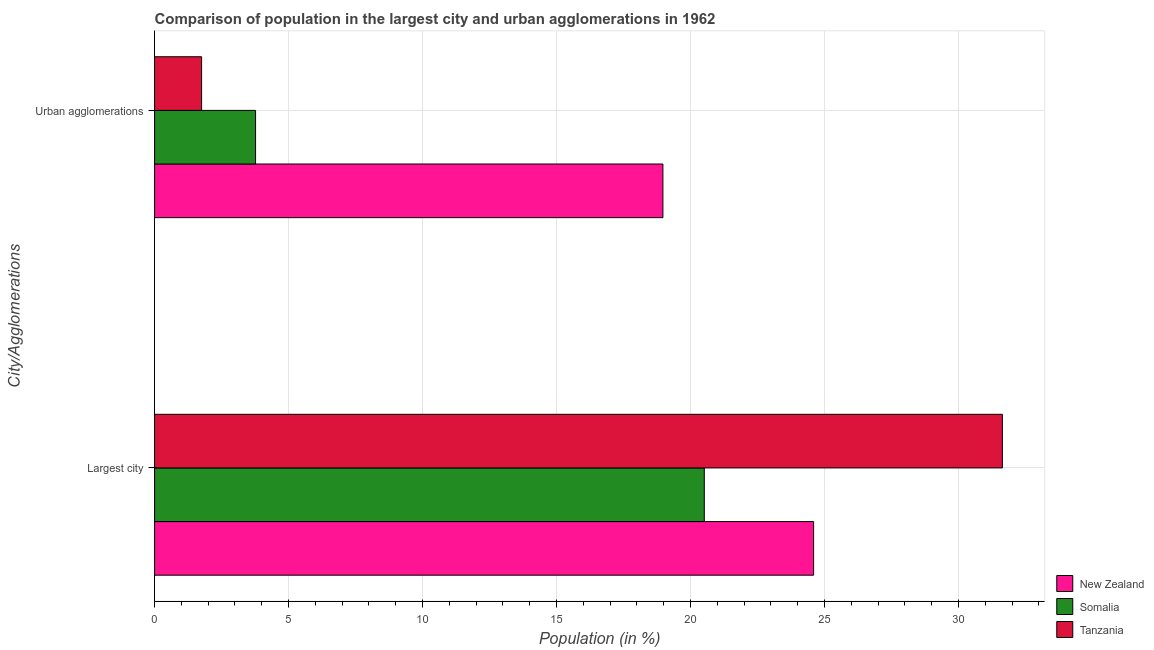How many different coloured bars are there?
Provide a succinct answer. 3. How many groups of bars are there?
Your answer should be very brief. 2. How many bars are there on the 1st tick from the top?
Your answer should be compact. 3. How many bars are there on the 2nd tick from the bottom?
Provide a succinct answer. 3. What is the label of the 1st group of bars from the top?
Offer a very short reply. Urban agglomerations. What is the population in urban agglomerations in Somalia?
Your answer should be very brief. 3.77. Across all countries, what is the maximum population in urban agglomerations?
Your response must be concise. 18.97. Across all countries, what is the minimum population in the largest city?
Offer a terse response. 20.52. In which country was the population in the largest city maximum?
Make the answer very short. Tanzania. In which country was the population in urban agglomerations minimum?
Keep it short and to the point. Tanzania. What is the total population in the largest city in the graph?
Provide a short and direct response. 76.75. What is the difference between the population in urban agglomerations in New Zealand and that in Tanzania?
Your answer should be compact. 17.22. What is the difference between the population in urban agglomerations in Somalia and the population in the largest city in Tanzania?
Provide a short and direct response. -27.87. What is the average population in the largest city per country?
Keep it short and to the point. 25.58. What is the difference between the population in urban agglomerations and population in the largest city in New Zealand?
Offer a very short reply. -5.62. In how many countries, is the population in urban agglomerations greater than 28 %?
Your answer should be very brief. 0. What is the ratio of the population in urban agglomerations in Tanzania to that in New Zealand?
Your answer should be very brief. 0.09. What does the 3rd bar from the top in Largest city represents?
Your response must be concise. New Zealand. What does the 3rd bar from the bottom in Urban agglomerations represents?
Your answer should be very brief. Tanzania. How many bars are there?
Your response must be concise. 6. Are all the bars in the graph horizontal?
Your answer should be very brief. Yes. How many countries are there in the graph?
Provide a short and direct response. 3. What is the difference between two consecutive major ticks on the X-axis?
Your answer should be very brief. 5. What is the title of the graph?
Your answer should be compact. Comparison of population in the largest city and urban agglomerations in 1962. Does "Least developed countries" appear as one of the legend labels in the graph?
Ensure brevity in your answer.  No. What is the label or title of the X-axis?
Your answer should be compact. Population (in %). What is the label or title of the Y-axis?
Make the answer very short. City/Agglomerations. What is the Population (in %) in New Zealand in Largest city?
Provide a short and direct response. 24.6. What is the Population (in %) in Somalia in Largest city?
Provide a short and direct response. 20.52. What is the Population (in %) of Tanzania in Largest city?
Your response must be concise. 31.64. What is the Population (in %) of New Zealand in Urban agglomerations?
Offer a terse response. 18.97. What is the Population (in %) in Somalia in Urban agglomerations?
Your answer should be compact. 3.77. What is the Population (in %) in Tanzania in Urban agglomerations?
Make the answer very short. 1.76. Across all City/Agglomerations, what is the maximum Population (in %) in New Zealand?
Make the answer very short. 24.6. Across all City/Agglomerations, what is the maximum Population (in %) in Somalia?
Provide a short and direct response. 20.52. Across all City/Agglomerations, what is the maximum Population (in %) in Tanzania?
Your answer should be compact. 31.64. Across all City/Agglomerations, what is the minimum Population (in %) in New Zealand?
Your response must be concise. 18.97. Across all City/Agglomerations, what is the minimum Population (in %) in Somalia?
Provide a succinct answer. 3.77. Across all City/Agglomerations, what is the minimum Population (in %) in Tanzania?
Provide a succinct answer. 1.76. What is the total Population (in %) in New Zealand in the graph?
Provide a short and direct response. 43.57. What is the total Population (in %) in Somalia in the graph?
Offer a terse response. 24.28. What is the total Population (in %) in Tanzania in the graph?
Offer a very short reply. 33.39. What is the difference between the Population (in %) in New Zealand in Largest city and that in Urban agglomerations?
Your answer should be very brief. 5.62. What is the difference between the Population (in %) in Somalia in Largest city and that in Urban agglomerations?
Your response must be concise. 16.75. What is the difference between the Population (in %) in Tanzania in Largest city and that in Urban agglomerations?
Make the answer very short. 29.88. What is the difference between the Population (in %) in New Zealand in Largest city and the Population (in %) in Somalia in Urban agglomerations?
Give a very brief answer. 20.83. What is the difference between the Population (in %) of New Zealand in Largest city and the Population (in %) of Tanzania in Urban agglomerations?
Offer a very short reply. 22.84. What is the difference between the Population (in %) in Somalia in Largest city and the Population (in %) in Tanzania in Urban agglomerations?
Provide a short and direct response. 18.76. What is the average Population (in %) of New Zealand per City/Agglomerations?
Make the answer very short. 21.78. What is the average Population (in %) of Somalia per City/Agglomerations?
Your answer should be compact. 12.14. What is the average Population (in %) in Tanzania per City/Agglomerations?
Ensure brevity in your answer.  16.7. What is the difference between the Population (in %) in New Zealand and Population (in %) in Somalia in Largest city?
Offer a very short reply. 4.08. What is the difference between the Population (in %) in New Zealand and Population (in %) in Tanzania in Largest city?
Your response must be concise. -7.04. What is the difference between the Population (in %) of Somalia and Population (in %) of Tanzania in Largest city?
Your answer should be very brief. -11.12. What is the difference between the Population (in %) of New Zealand and Population (in %) of Somalia in Urban agglomerations?
Provide a short and direct response. 15.2. What is the difference between the Population (in %) in New Zealand and Population (in %) in Tanzania in Urban agglomerations?
Give a very brief answer. 17.22. What is the difference between the Population (in %) of Somalia and Population (in %) of Tanzania in Urban agglomerations?
Ensure brevity in your answer.  2.01. What is the ratio of the Population (in %) in New Zealand in Largest city to that in Urban agglomerations?
Offer a terse response. 1.3. What is the ratio of the Population (in %) in Somalia in Largest city to that in Urban agglomerations?
Provide a short and direct response. 5.44. What is the ratio of the Population (in %) of Tanzania in Largest city to that in Urban agglomerations?
Give a very brief answer. 18.03. What is the difference between the highest and the second highest Population (in %) of New Zealand?
Keep it short and to the point. 5.62. What is the difference between the highest and the second highest Population (in %) in Somalia?
Provide a succinct answer. 16.75. What is the difference between the highest and the second highest Population (in %) of Tanzania?
Give a very brief answer. 29.88. What is the difference between the highest and the lowest Population (in %) of New Zealand?
Give a very brief answer. 5.62. What is the difference between the highest and the lowest Population (in %) of Somalia?
Ensure brevity in your answer.  16.75. What is the difference between the highest and the lowest Population (in %) in Tanzania?
Ensure brevity in your answer.  29.88. 